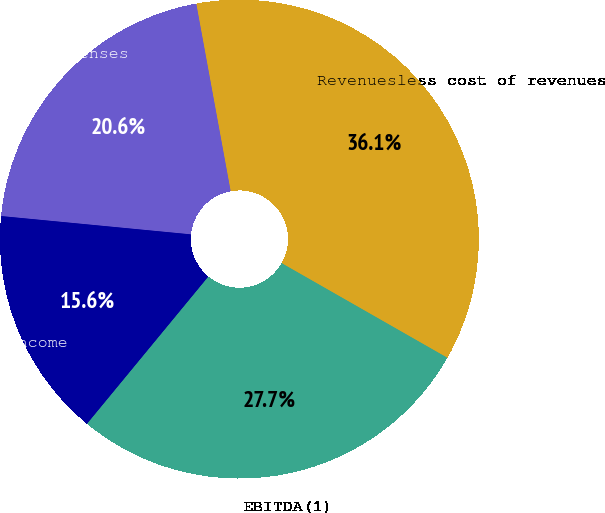Convert chart. <chart><loc_0><loc_0><loc_500><loc_500><pie_chart><fcel>Revenuesless cost of revenues<fcel>Operating expenses<fcel>Operating income<fcel>EBITDA(1)<nl><fcel>36.14%<fcel>20.58%<fcel>15.56%<fcel>27.71%<nl></chart> 